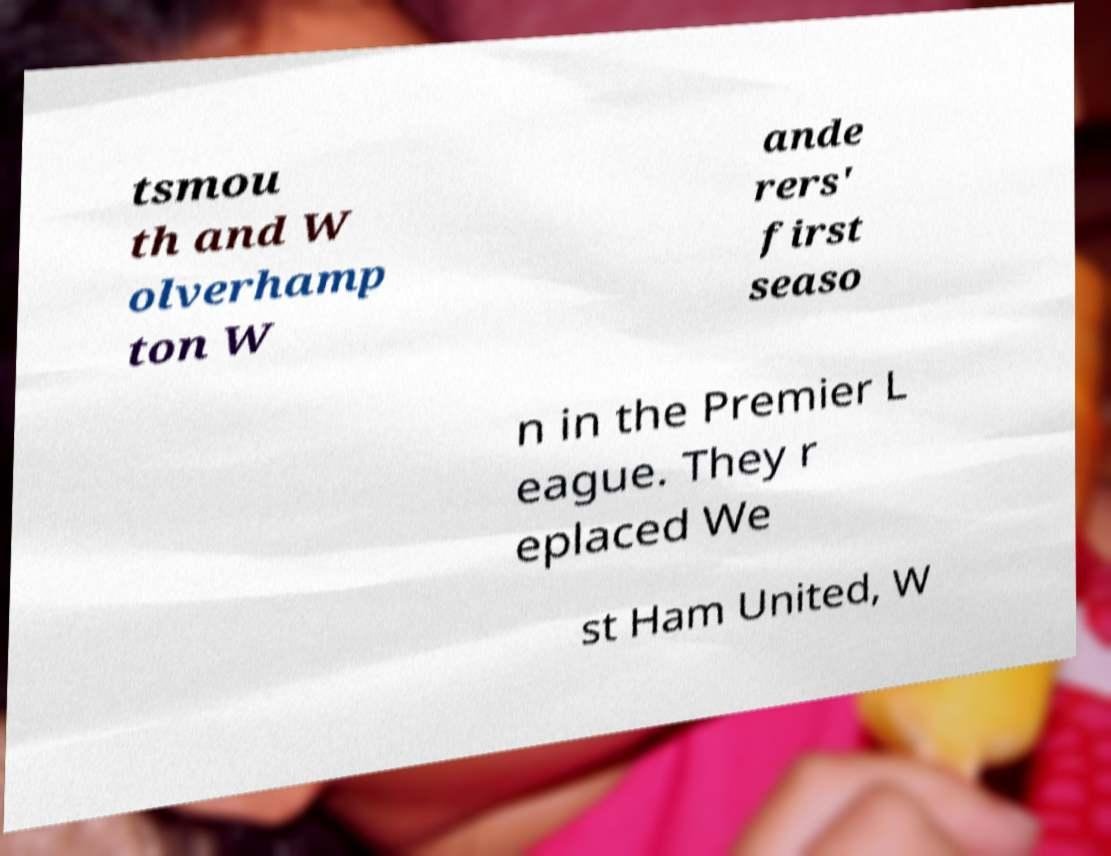For documentation purposes, I need the text within this image transcribed. Could you provide that? tsmou th and W olverhamp ton W ande rers' first seaso n in the Premier L eague. They r eplaced We st Ham United, W 